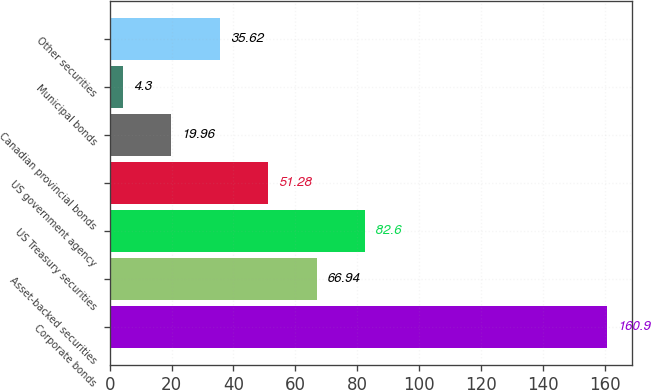Convert chart. <chart><loc_0><loc_0><loc_500><loc_500><bar_chart><fcel>Corporate bonds<fcel>Asset-backed securities<fcel>US Treasury securities<fcel>US government agency<fcel>Canadian provincial bonds<fcel>Municipal bonds<fcel>Other securities<nl><fcel>160.9<fcel>66.94<fcel>82.6<fcel>51.28<fcel>19.96<fcel>4.3<fcel>35.62<nl></chart> 